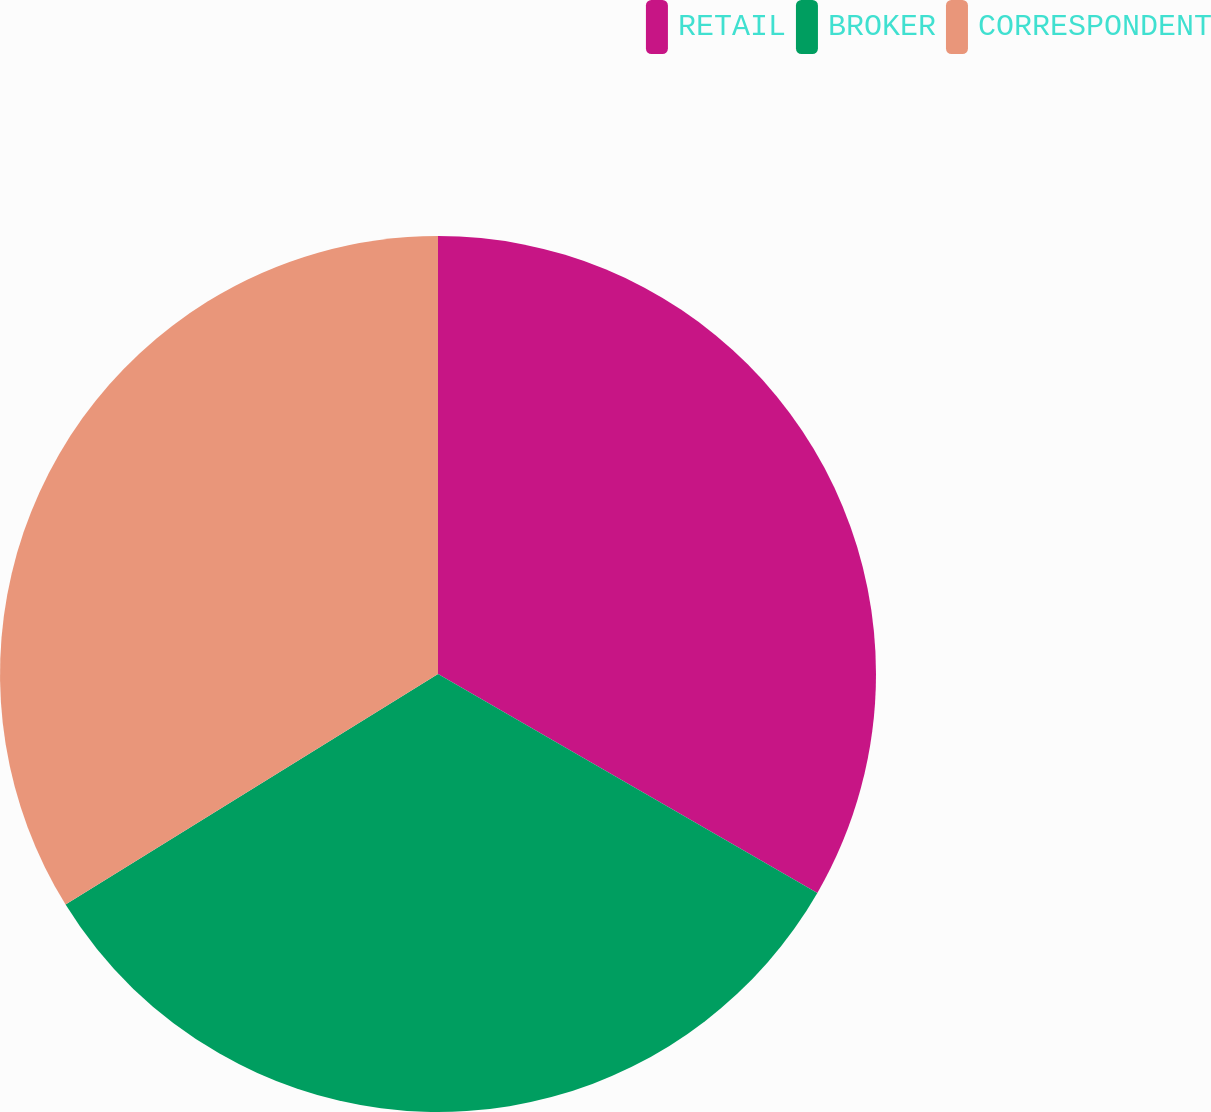<chart> <loc_0><loc_0><loc_500><loc_500><pie_chart><fcel>RETAIL<fcel>BROKER<fcel>CORRESPONDENT<nl><fcel>33.33%<fcel>32.85%<fcel>33.82%<nl></chart> 